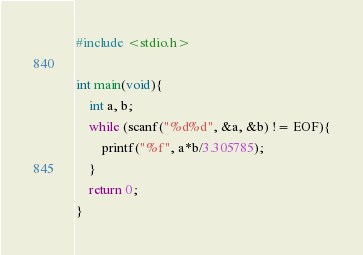Convert code to text. <code><loc_0><loc_0><loc_500><loc_500><_C_>#include <stdio.h>

int main(void){
	int a, b;
	while (scanf("%d%d", &a, &b) != EOF){
		printf("%f", a*b/3.305785);
	}
	return 0;
}</code> 